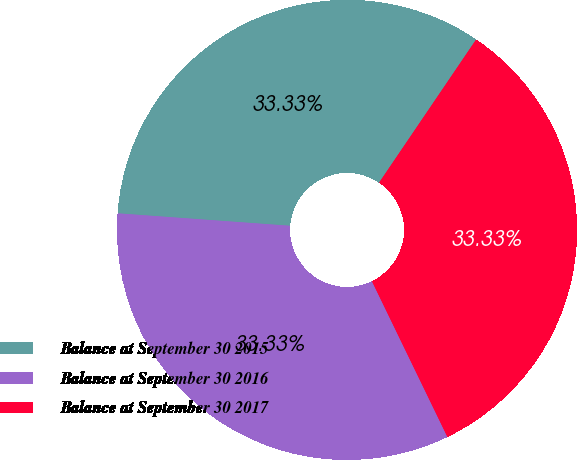Convert chart to OTSL. <chart><loc_0><loc_0><loc_500><loc_500><pie_chart><fcel>Balance at September 30 2015<fcel>Balance at September 30 2016<fcel>Balance at September 30 2017<nl><fcel>33.33%<fcel>33.33%<fcel>33.33%<nl></chart> 